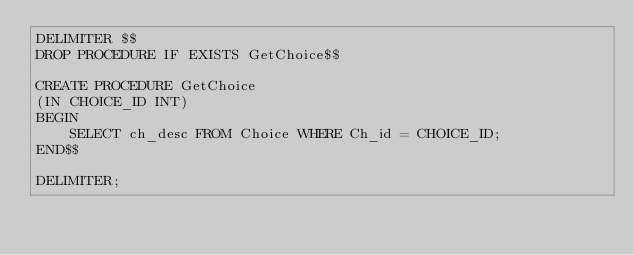<code> <loc_0><loc_0><loc_500><loc_500><_SQL_>DELIMITER $$
DROP PROCEDURE IF EXISTS GetChoice$$

CREATE PROCEDURE GetChoice
(IN CHOICE_ID INT)
BEGIN
    SELECT ch_desc FROM Choice WHERE Ch_id = CHOICE_ID;
END$$

DELIMITER;</code> 